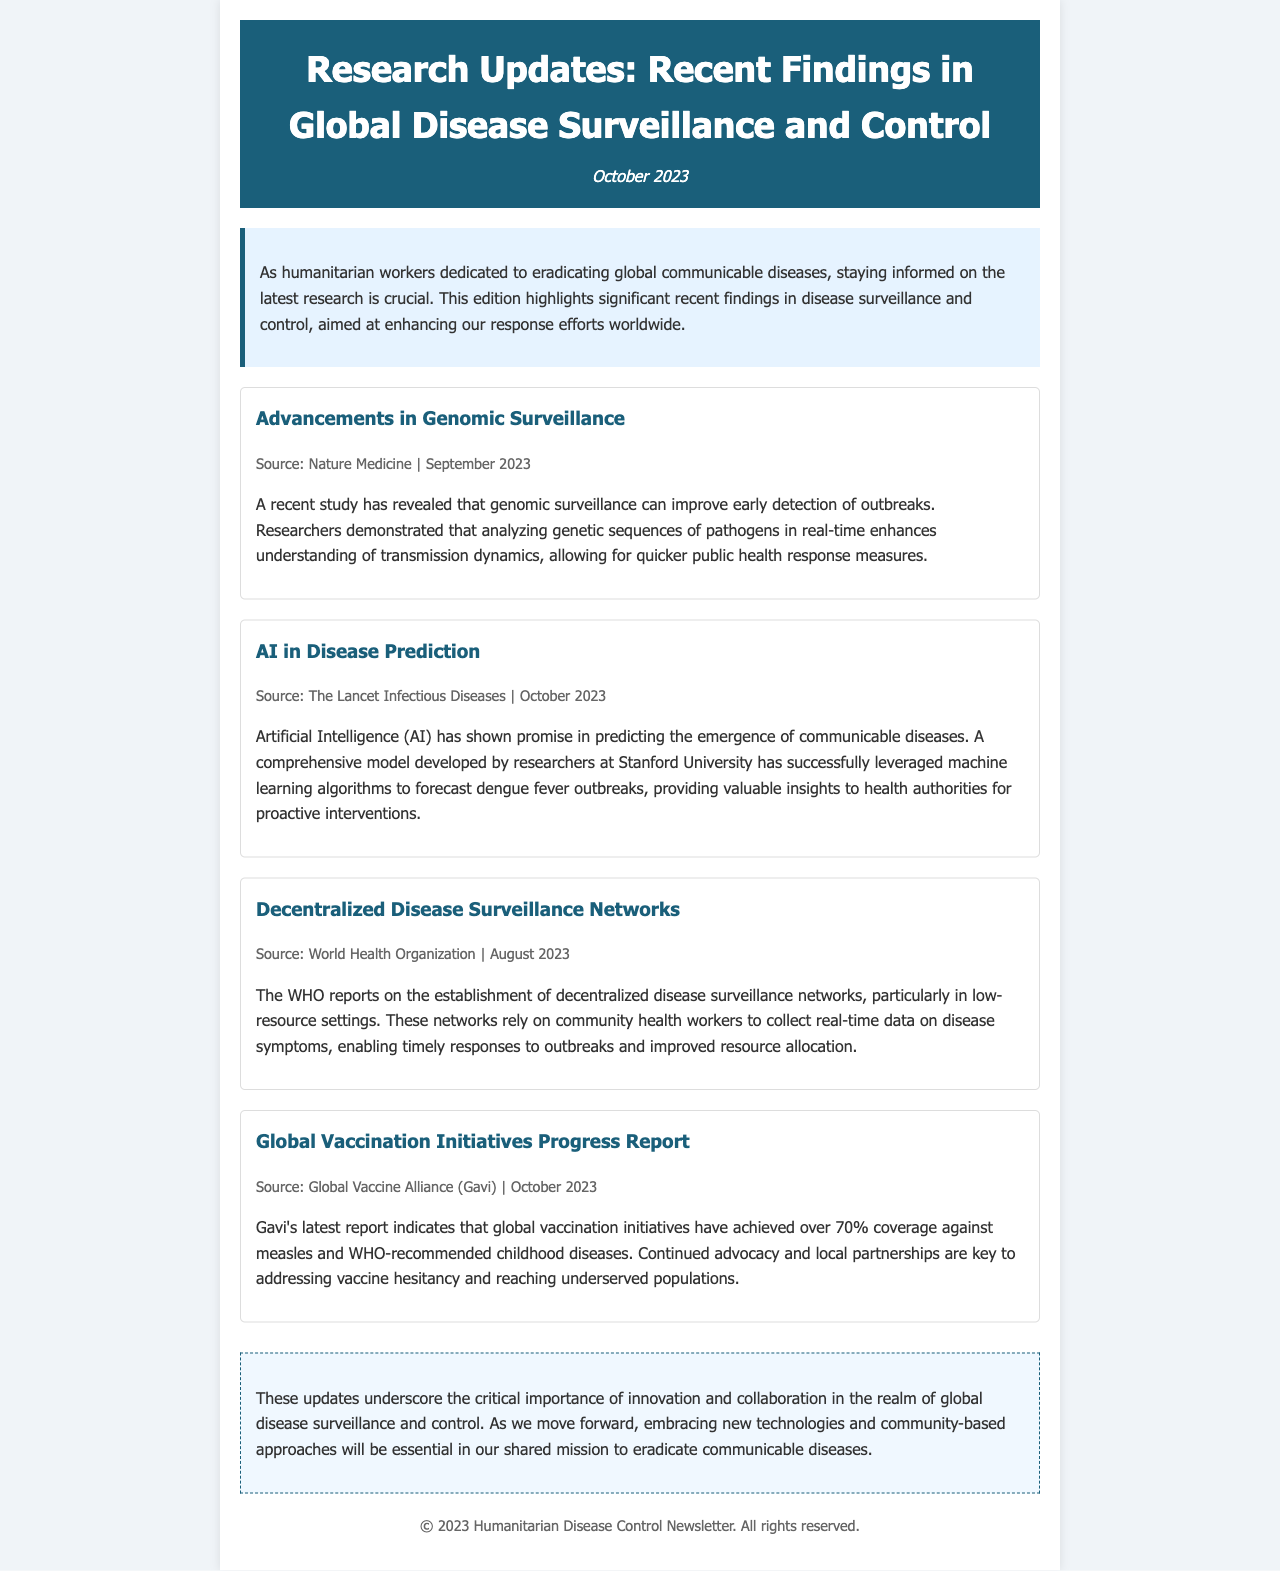What is the title of the newsletter? The title of the newsletter is stated at the top of the document.
Answer: Research Updates: Recent Findings in Global Disease Surveillance and Control When was the newsletter published? The publication date is mentioned right under the title.
Answer: October 2023 How many updates are featured in the newsletter? The total number of updates can be counted in the document.
Answer: Four Which organization reported on decentralized disease surveillance networks? The source of this update is specified in the update section.
Answer: World Health Organization What percentage coverage has been achieved against measles according to Gavi's report? This specific percentage is mentioned in the report update.
Answer: Over 70% What technology is highlighted for predicting disease outbreaks? The specific technology that is emphasized is described in one of the updates.
Answer: Artificial Intelligence (AI) What role do community health workers play in the new surveillance networks? This role is outlined within the description of decentralized networks.
Answer: Collecting real-time data What is a key focus for vaccination initiatives according to the newsletter? This focus is mentioned in relation to partner involvement and addressing challenges.
Answer: Vaccine hesitancy 